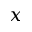<formula> <loc_0><loc_0><loc_500><loc_500>x</formula> 